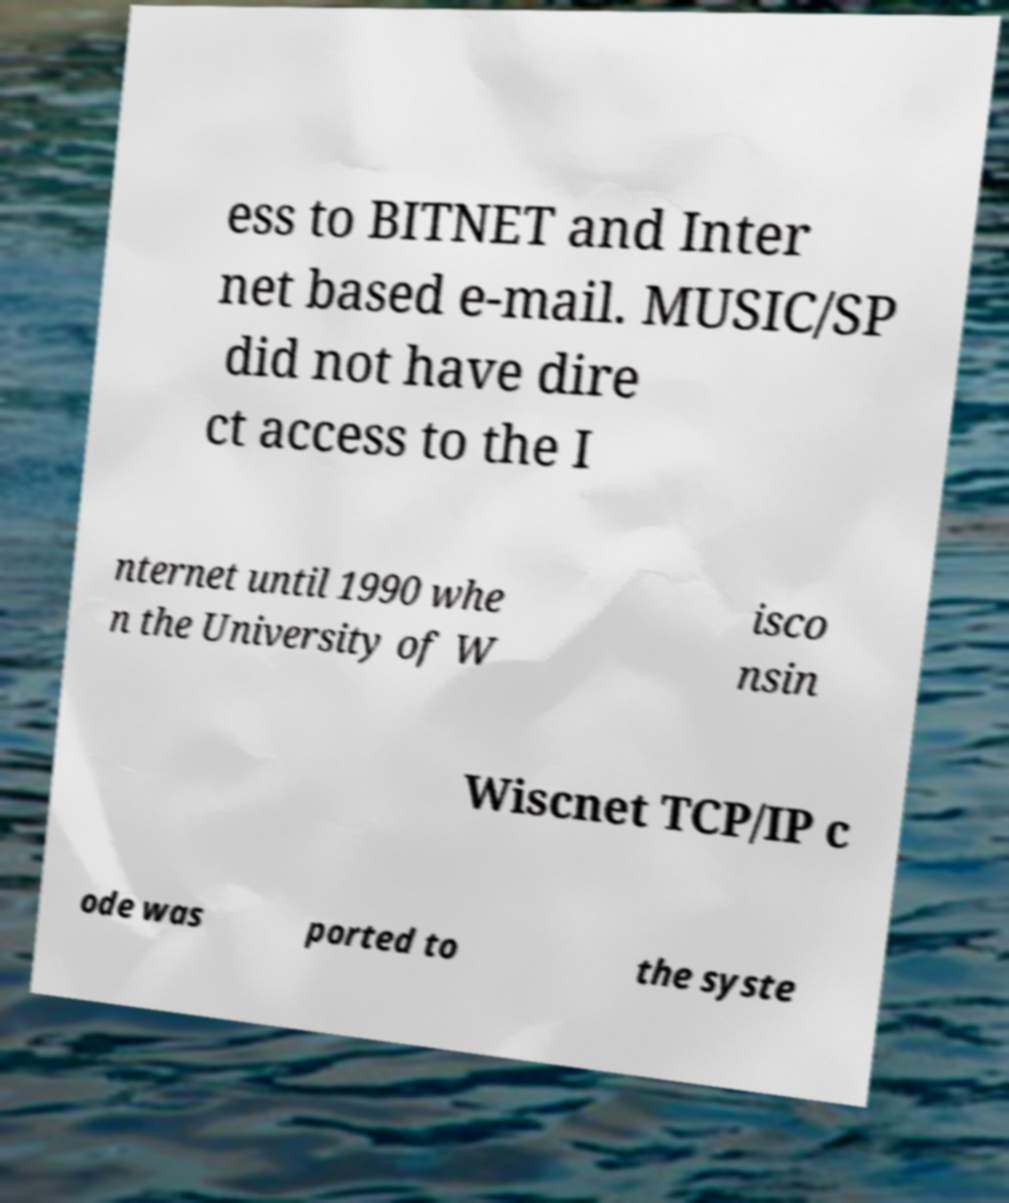What messages or text are displayed in this image? I need them in a readable, typed format. ess to BITNET and Inter net based e-mail. MUSIC/SP did not have dire ct access to the I nternet until 1990 whe n the University of W isco nsin Wiscnet TCP/IP c ode was ported to the syste 